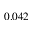<formula> <loc_0><loc_0><loc_500><loc_500>0 . 0 4 2</formula> 